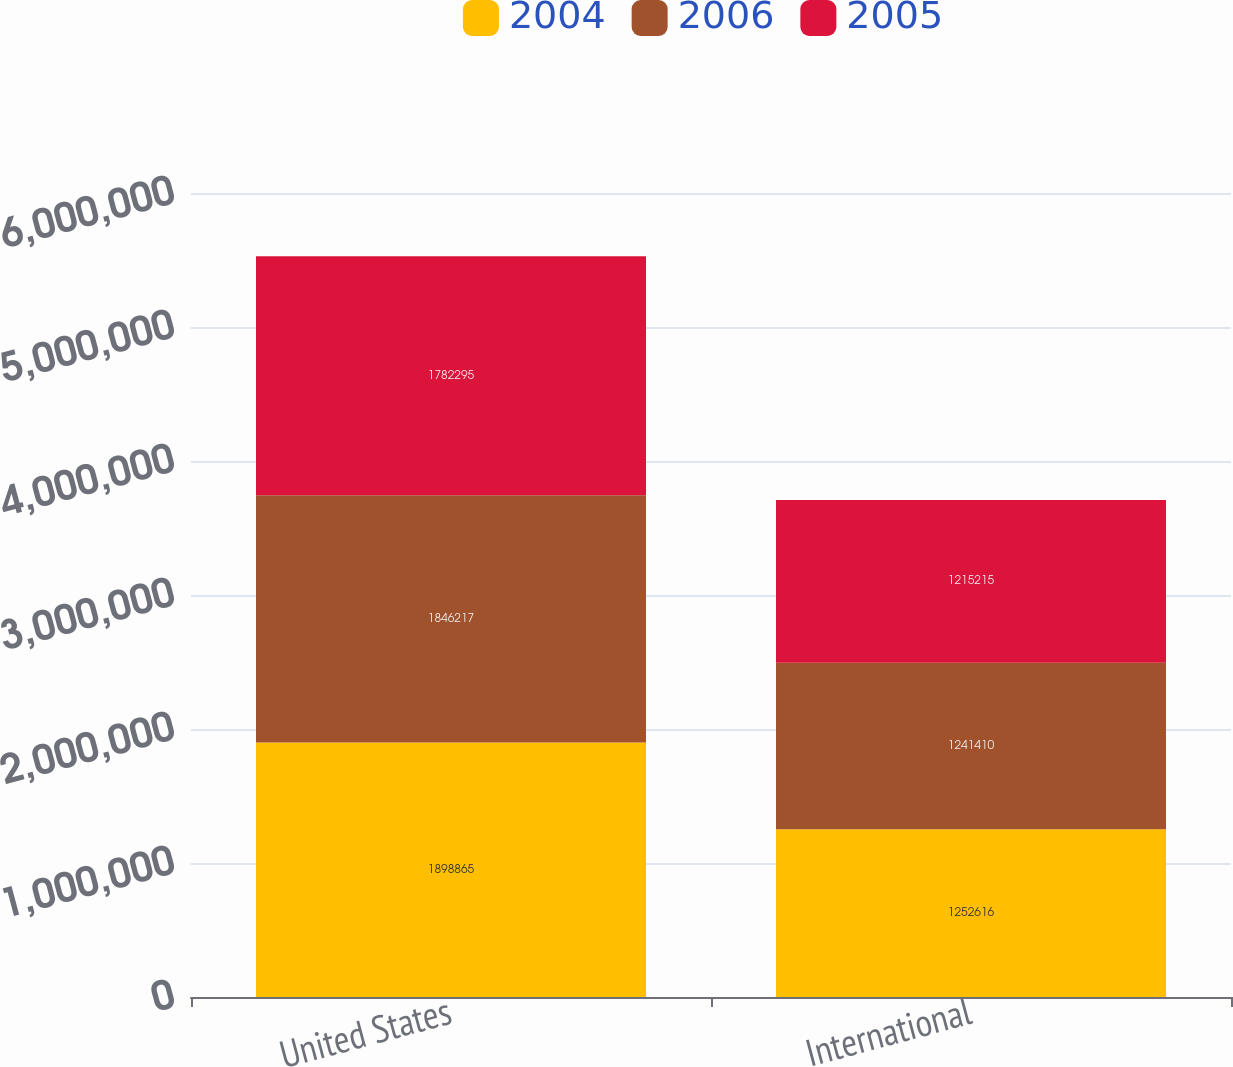<chart> <loc_0><loc_0><loc_500><loc_500><stacked_bar_chart><ecel><fcel>United States<fcel>International<nl><fcel>2004<fcel>1.89886e+06<fcel>1.25262e+06<nl><fcel>2006<fcel>1.84622e+06<fcel>1.24141e+06<nl><fcel>2005<fcel>1.7823e+06<fcel>1.21522e+06<nl></chart> 